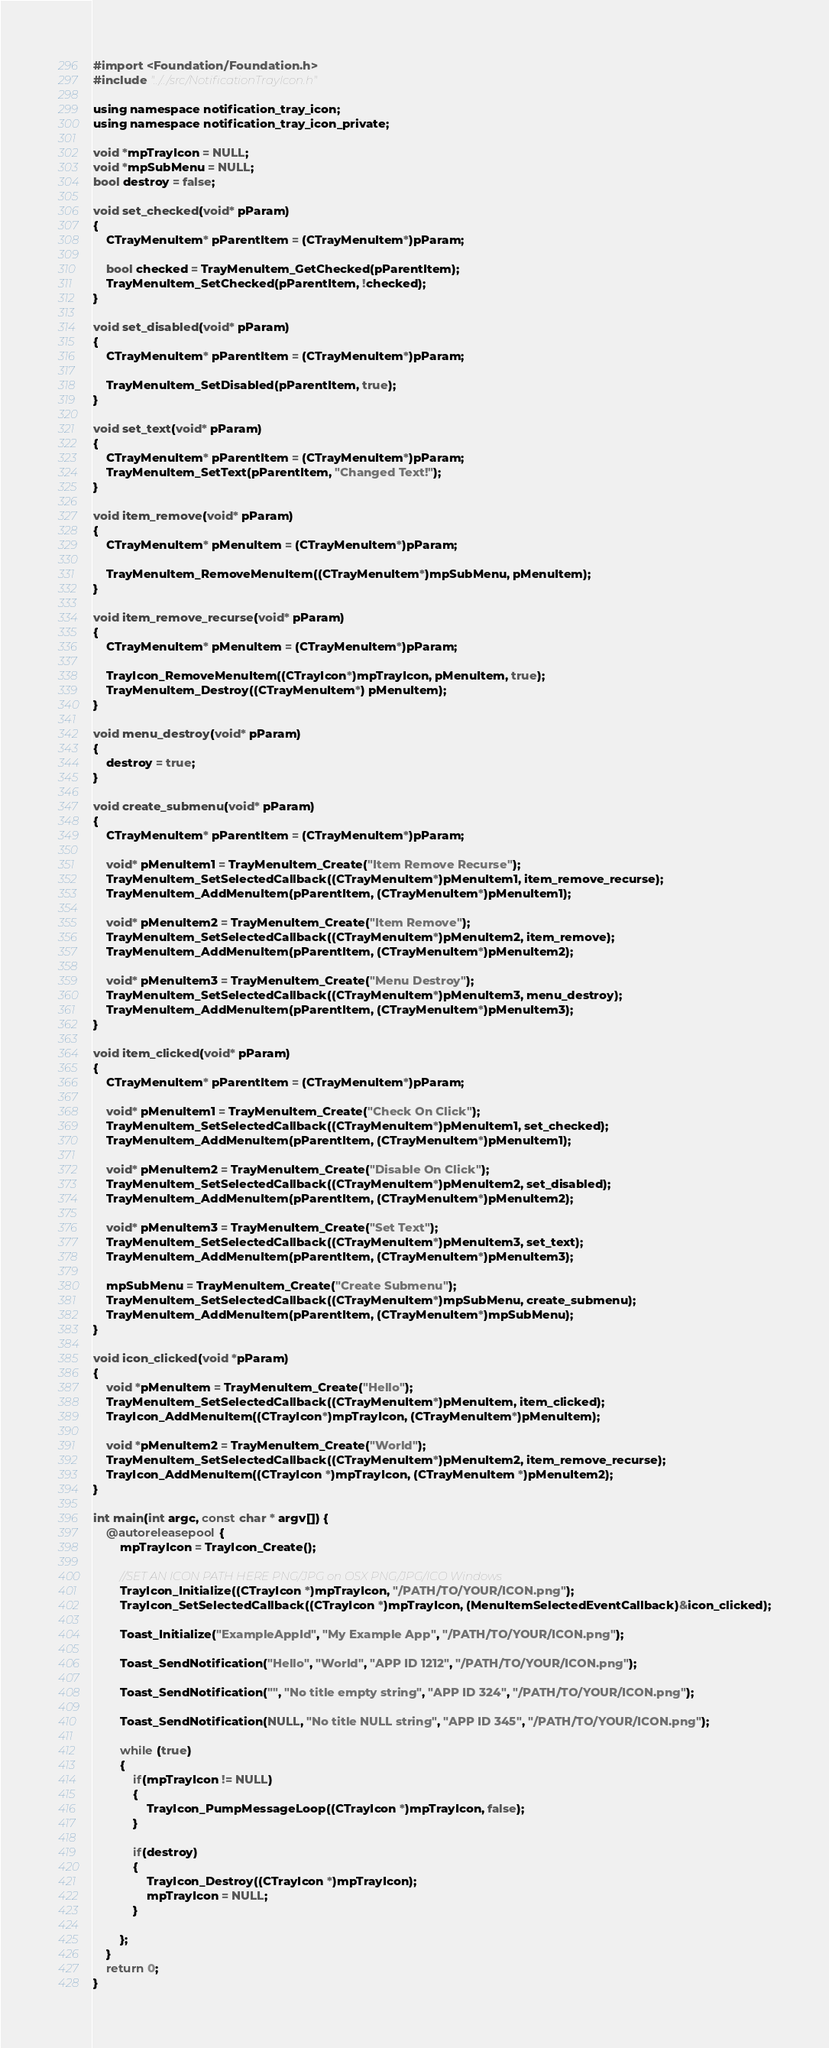<code> <loc_0><loc_0><loc_500><loc_500><_ObjectiveC_>#import <Foundation/Foundation.h>
#include "../../src/NotificationTrayIcon.h"

using namespace notification_tray_icon;
using namespace notification_tray_icon_private;

void *mpTrayIcon = NULL;
void *mpSubMenu = NULL;
bool destroy = false;

void set_checked(void* pParam)
{
    CTrayMenuItem* pParentItem = (CTrayMenuItem*)pParam;

    bool checked = TrayMenuItem_GetChecked(pParentItem);
    TrayMenuItem_SetChecked(pParentItem, !checked);
}

void set_disabled(void* pParam)
{
    CTrayMenuItem* pParentItem = (CTrayMenuItem*)pParam;

    TrayMenuItem_SetDisabled(pParentItem, true);
}

void set_text(void* pParam)
{
    CTrayMenuItem* pParentItem = (CTrayMenuItem*)pParam;
    TrayMenuItem_SetText(pParentItem, "Changed Text!");
}

void item_remove(void* pParam)
{
    CTrayMenuItem* pMenuItem = (CTrayMenuItem*)pParam;

    TrayMenuItem_RemoveMenuItem((CTrayMenuItem*)mpSubMenu, pMenuItem);
}

void item_remove_recurse(void* pParam)
{
    CTrayMenuItem* pMenuItem = (CTrayMenuItem*)pParam;

    TrayIcon_RemoveMenuItem((CTrayIcon*)mpTrayIcon, pMenuItem, true);
    TrayMenuItem_Destroy((CTrayMenuItem*) pMenuItem);
}

void menu_destroy(void* pParam)
{
    destroy = true;
}

void create_submenu(void* pParam)
{
    CTrayMenuItem* pParentItem = (CTrayMenuItem*)pParam;

    void* pMenuItem1 = TrayMenuItem_Create("Item Remove Recurse");
    TrayMenuItem_SetSelectedCallback((CTrayMenuItem*)pMenuItem1, item_remove_recurse);
    TrayMenuItem_AddMenuItem(pParentItem, (CTrayMenuItem*)pMenuItem1);

    void* pMenuItem2 = TrayMenuItem_Create("Item Remove");
    TrayMenuItem_SetSelectedCallback((CTrayMenuItem*)pMenuItem2, item_remove);
    TrayMenuItem_AddMenuItem(pParentItem, (CTrayMenuItem*)pMenuItem2);
    
    void* pMenuItem3 = TrayMenuItem_Create("Menu Destroy");
    TrayMenuItem_SetSelectedCallback((CTrayMenuItem*)pMenuItem3, menu_destroy);
    TrayMenuItem_AddMenuItem(pParentItem, (CTrayMenuItem*)pMenuItem3);
}

void item_clicked(void* pParam)
{
    CTrayMenuItem* pParentItem = (CTrayMenuItem*)pParam;

    void* pMenuItem1 = TrayMenuItem_Create("Check On Click");
    TrayMenuItem_SetSelectedCallback((CTrayMenuItem*)pMenuItem1, set_checked);
    TrayMenuItem_AddMenuItem(pParentItem, (CTrayMenuItem*)pMenuItem1);

    void* pMenuItem2 = TrayMenuItem_Create("Disable On Click");
    TrayMenuItem_SetSelectedCallback((CTrayMenuItem*)pMenuItem2, set_disabled);
    TrayMenuItem_AddMenuItem(pParentItem, (CTrayMenuItem*)pMenuItem2);

    void* pMenuItem3 = TrayMenuItem_Create("Set Text");
    TrayMenuItem_SetSelectedCallback((CTrayMenuItem*)pMenuItem3, set_text);
    TrayMenuItem_AddMenuItem(pParentItem, (CTrayMenuItem*)pMenuItem3);

    mpSubMenu = TrayMenuItem_Create("Create Submenu");
    TrayMenuItem_SetSelectedCallback((CTrayMenuItem*)mpSubMenu, create_submenu);
    TrayMenuItem_AddMenuItem(pParentItem, (CTrayMenuItem*)mpSubMenu);
}

void icon_clicked(void *pParam)
{
    void *pMenuItem = TrayMenuItem_Create("Hello");
    TrayMenuItem_SetSelectedCallback((CTrayMenuItem*)pMenuItem, item_clicked);
    TrayIcon_AddMenuItem((CTrayIcon*)mpTrayIcon, (CTrayMenuItem*)pMenuItem);

    void *pMenuItem2 = TrayMenuItem_Create("World");
    TrayMenuItem_SetSelectedCallback((CTrayMenuItem*)pMenuItem2, item_remove_recurse);
    TrayIcon_AddMenuItem((CTrayIcon *)mpTrayIcon, (CTrayMenuItem *)pMenuItem2);
}

int main(int argc, const char * argv[]) {
    @autoreleasepool {
        mpTrayIcon = TrayIcon_Create();
        
        //SET AN ICON PATH HERE PNG/JPG on OSX PNG/JPG/ICO Windows
        TrayIcon_Initialize((CTrayIcon *)mpTrayIcon, "/PATH/TO/YOUR/ICON.png");
        TrayIcon_SetSelectedCallback((CTrayIcon *)mpTrayIcon, (MenuItemSelectedEventCallback)&icon_clicked);
        
        Toast_Initialize("ExampleAppId", "My Example App", "/PATH/TO/YOUR/ICON.png");

        Toast_SendNotification("Hello", "World", "APP ID 1212", "/PATH/TO/YOUR/ICON.png");

        Toast_SendNotification("", "No title empty string", "APP ID 324", "/PATH/TO/YOUR/ICON.png");

        Toast_SendNotification(NULL, "No title NULL string", "APP ID 345", "/PATH/TO/YOUR/ICON.png");
        
        while (true)
        {
            if(mpTrayIcon != NULL)
            {
                TrayIcon_PumpMessageLoop((CTrayIcon *)mpTrayIcon, false);
            }
            
            if(destroy)
            {
                TrayIcon_Destroy((CTrayIcon *)mpTrayIcon);
                mpTrayIcon = NULL;
            }
        
        };
    }
    return 0;
}
</code> 